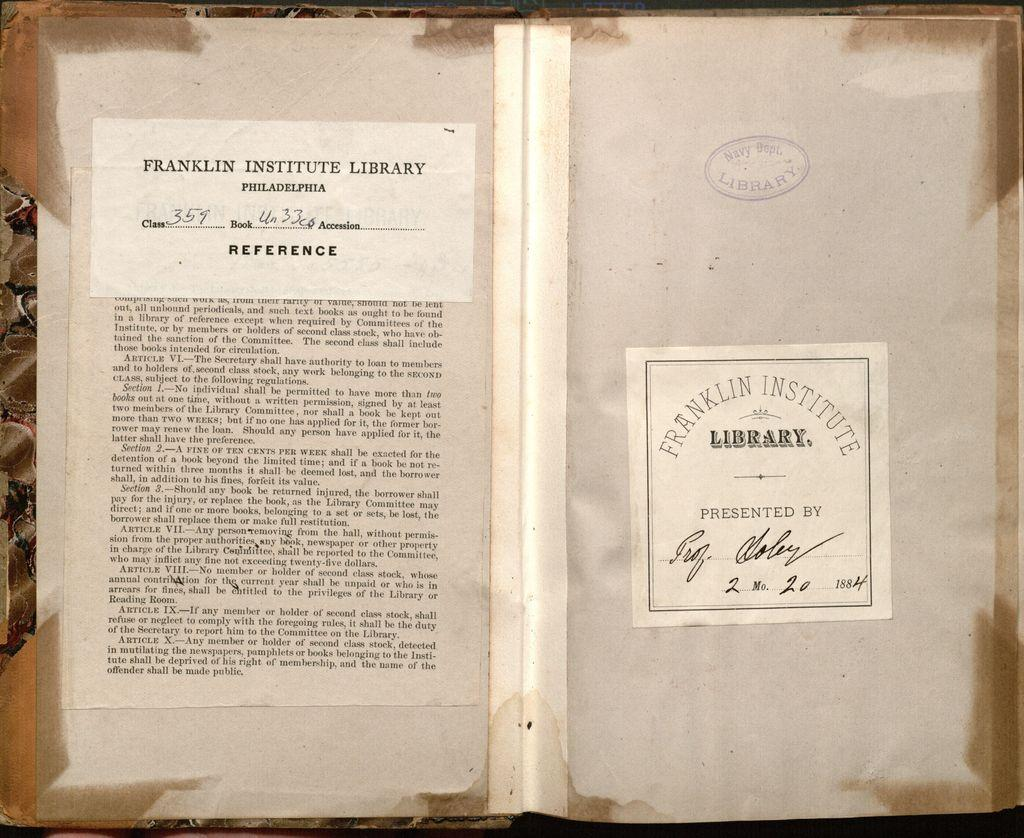<image>
Share a concise interpretation of the image provided. The document shown is from the Franklin Institute Library. 